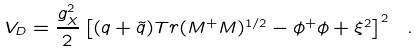<formula> <loc_0><loc_0><loc_500><loc_500>V _ { D } = { \frac { g _ { X } ^ { 2 } } { 2 } } \left [ ( q + { \tilde { q } } ) T r ( M ^ { + } M ) ^ { 1 / 2 } - \phi ^ { + } \phi + \xi ^ { 2 } \right ] ^ { 2 } \ .</formula> 